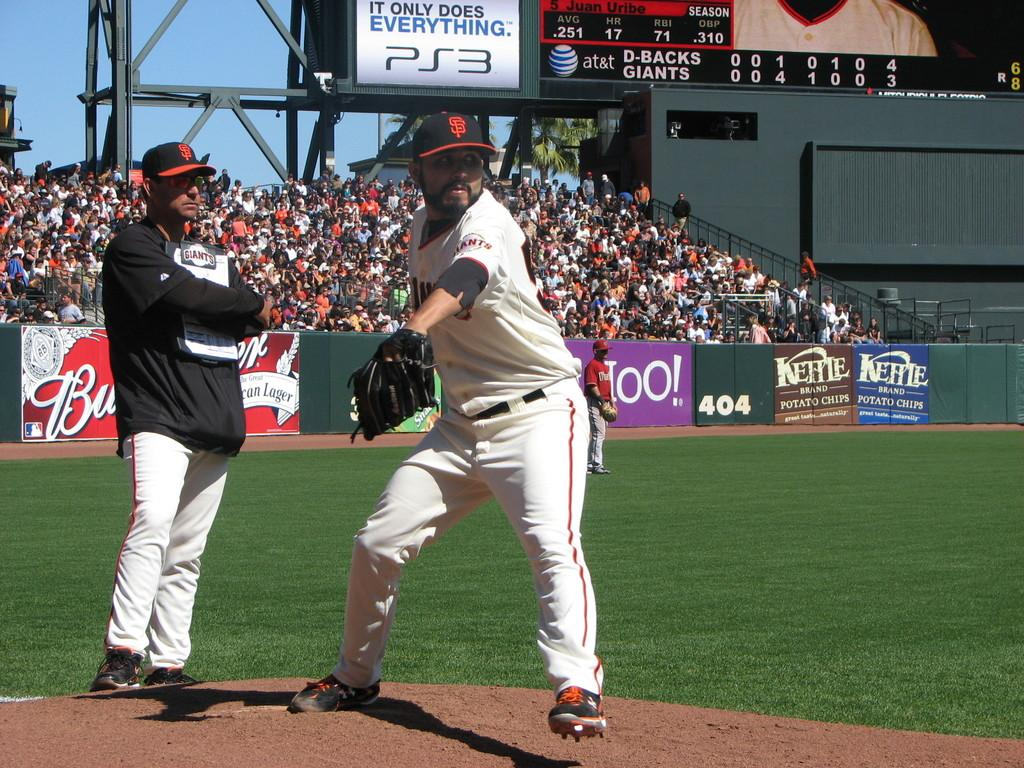<image>
Present a compact description of the photo's key features. A Giants pitcher throws the ball as the coach watches from behind. 